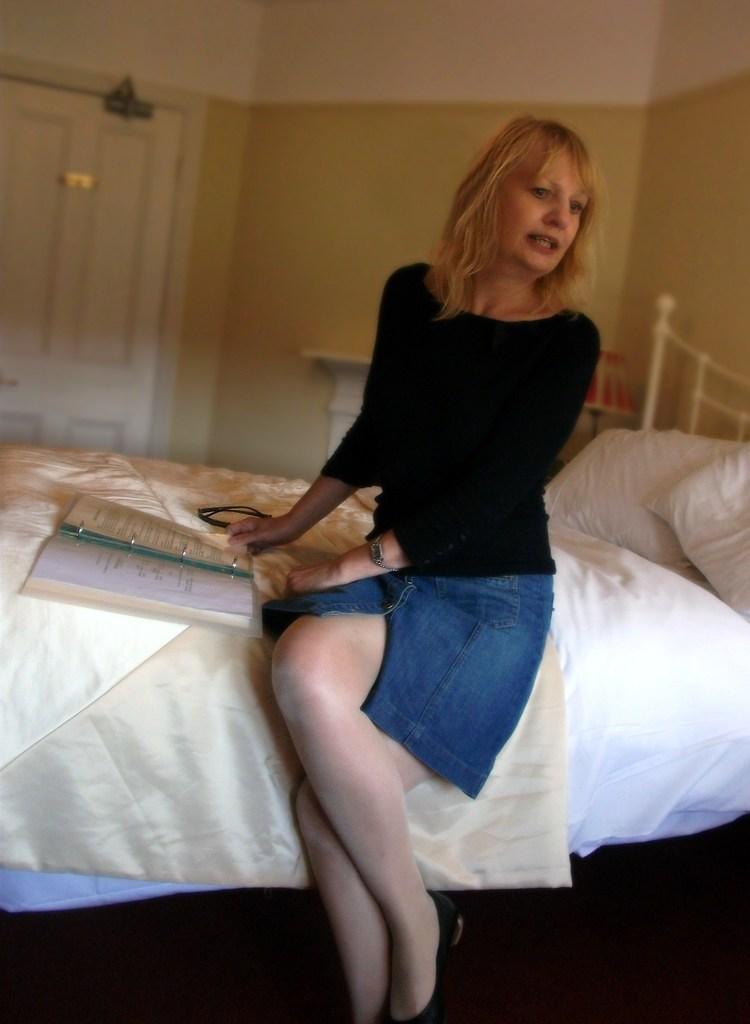How would you summarize this image in a sentence or two? In this picture I can see a woman sitting on the bed and holding book, side there are some pillows, behind I can see a door to the wall. 